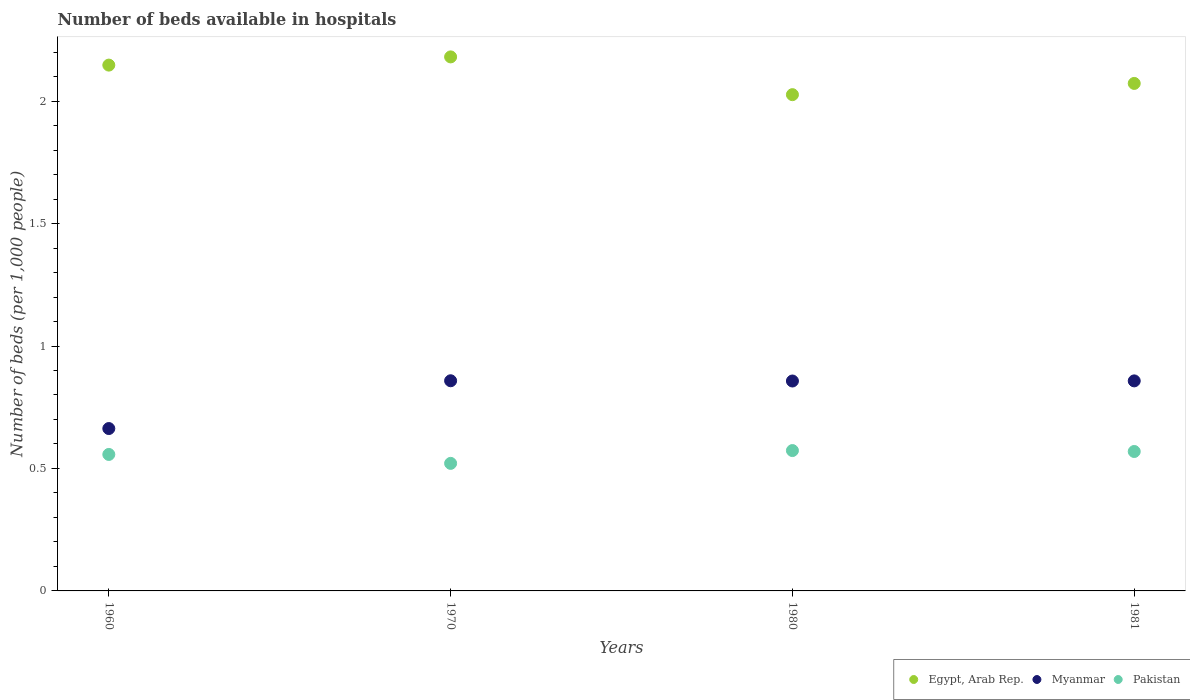Is the number of dotlines equal to the number of legend labels?
Provide a short and direct response. Yes. What is the number of beds in the hospiatls of in Pakistan in 1970?
Your answer should be compact. 0.52. Across all years, what is the maximum number of beds in the hospiatls of in Pakistan?
Provide a succinct answer. 0.57. Across all years, what is the minimum number of beds in the hospiatls of in Egypt, Arab Rep.?
Provide a succinct answer. 2.03. In which year was the number of beds in the hospiatls of in Myanmar maximum?
Offer a very short reply. 1970. In which year was the number of beds in the hospiatls of in Myanmar minimum?
Keep it short and to the point. 1960. What is the total number of beds in the hospiatls of in Myanmar in the graph?
Provide a short and direct response. 3.24. What is the difference between the number of beds in the hospiatls of in Pakistan in 1980 and that in 1981?
Keep it short and to the point. 0. What is the difference between the number of beds in the hospiatls of in Egypt, Arab Rep. in 1981 and the number of beds in the hospiatls of in Pakistan in 1980?
Your response must be concise. 1.5. What is the average number of beds in the hospiatls of in Egypt, Arab Rep. per year?
Offer a very short reply. 2.11. In the year 1981, what is the difference between the number of beds in the hospiatls of in Myanmar and number of beds in the hospiatls of in Pakistan?
Offer a very short reply. 0.29. In how many years, is the number of beds in the hospiatls of in Egypt, Arab Rep. greater than 0.30000000000000004?
Offer a terse response. 4. What is the ratio of the number of beds in the hospiatls of in Egypt, Arab Rep. in 1960 to that in 1970?
Your response must be concise. 0.98. Is the number of beds in the hospiatls of in Egypt, Arab Rep. in 1970 less than that in 1980?
Your answer should be compact. No. What is the difference between the highest and the second highest number of beds in the hospiatls of in Myanmar?
Your answer should be very brief. 0. What is the difference between the highest and the lowest number of beds in the hospiatls of in Pakistan?
Provide a succinct answer. 0.05. Is the sum of the number of beds in the hospiatls of in Egypt, Arab Rep. in 1960 and 1980 greater than the maximum number of beds in the hospiatls of in Myanmar across all years?
Your answer should be compact. Yes. Does the number of beds in the hospiatls of in Myanmar monotonically increase over the years?
Make the answer very short. No. Is the number of beds in the hospiatls of in Myanmar strictly less than the number of beds in the hospiatls of in Egypt, Arab Rep. over the years?
Offer a terse response. Yes. What is the difference between two consecutive major ticks on the Y-axis?
Give a very brief answer. 0.5. How many legend labels are there?
Offer a terse response. 3. How are the legend labels stacked?
Your response must be concise. Horizontal. What is the title of the graph?
Keep it short and to the point. Number of beds available in hospitals. Does "St. Martin (French part)" appear as one of the legend labels in the graph?
Give a very brief answer. No. What is the label or title of the X-axis?
Your answer should be compact. Years. What is the label or title of the Y-axis?
Your response must be concise. Number of beds (per 1,0 people). What is the Number of beds (per 1,000 people) of Egypt, Arab Rep. in 1960?
Keep it short and to the point. 2.15. What is the Number of beds (per 1,000 people) in Myanmar in 1960?
Offer a terse response. 0.66. What is the Number of beds (per 1,000 people) in Pakistan in 1960?
Your answer should be compact. 0.56. What is the Number of beds (per 1,000 people) in Egypt, Arab Rep. in 1970?
Offer a very short reply. 2.18. What is the Number of beds (per 1,000 people) of Myanmar in 1970?
Your response must be concise. 0.86. What is the Number of beds (per 1,000 people) in Pakistan in 1970?
Keep it short and to the point. 0.52. What is the Number of beds (per 1,000 people) of Egypt, Arab Rep. in 1980?
Provide a short and direct response. 2.03. What is the Number of beds (per 1,000 people) in Myanmar in 1980?
Your response must be concise. 0.86. What is the Number of beds (per 1,000 people) of Pakistan in 1980?
Provide a short and direct response. 0.57. What is the Number of beds (per 1,000 people) of Egypt, Arab Rep. in 1981?
Your answer should be compact. 2.07. What is the Number of beds (per 1,000 people) in Myanmar in 1981?
Make the answer very short. 0.86. What is the Number of beds (per 1,000 people) in Pakistan in 1981?
Your response must be concise. 0.57. Across all years, what is the maximum Number of beds (per 1,000 people) of Egypt, Arab Rep.?
Make the answer very short. 2.18. Across all years, what is the maximum Number of beds (per 1,000 people) in Myanmar?
Offer a terse response. 0.86. Across all years, what is the maximum Number of beds (per 1,000 people) in Pakistan?
Your response must be concise. 0.57. Across all years, what is the minimum Number of beds (per 1,000 people) of Egypt, Arab Rep.?
Your answer should be compact. 2.03. Across all years, what is the minimum Number of beds (per 1,000 people) of Myanmar?
Provide a succinct answer. 0.66. Across all years, what is the minimum Number of beds (per 1,000 people) of Pakistan?
Keep it short and to the point. 0.52. What is the total Number of beds (per 1,000 people) in Egypt, Arab Rep. in the graph?
Offer a terse response. 8.43. What is the total Number of beds (per 1,000 people) in Myanmar in the graph?
Keep it short and to the point. 3.24. What is the total Number of beds (per 1,000 people) of Pakistan in the graph?
Give a very brief answer. 2.22. What is the difference between the Number of beds (per 1,000 people) of Egypt, Arab Rep. in 1960 and that in 1970?
Make the answer very short. -0.03. What is the difference between the Number of beds (per 1,000 people) of Myanmar in 1960 and that in 1970?
Offer a very short reply. -0.2. What is the difference between the Number of beds (per 1,000 people) in Pakistan in 1960 and that in 1970?
Offer a terse response. 0.04. What is the difference between the Number of beds (per 1,000 people) in Egypt, Arab Rep. in 1960 and that in 1980?
Make the answer very short. 0.12. What is the difference between the Number of beds (per 1,000 people) in Myanmar in 1960 and that in 1980?
Your answer should be compact. -0.19. What is the difference between the Number of beds (per 1,000 people) in Pakistan in 1960 and that in 1980?
Provide a succinct answer. -0.02. What is the difference between the Number of beds (per 1,000 people) in Egypt, Arab Rep. in 1960 and that in 1981?
Your response must be concise. 0.07. What is the difference between the Number of beds (per 1,000 people) of Myanmar in 1960 and that in 1981?
Provide a succinct answer. -0.19. What is the difference between the Number of beds (per 1,000 people) of Pakistan in 1960 and that in 1981?
Keep it short and to the point. -0.01. What is the difference between the Number of beds (per 1,000 people) in Egypt, Arab Rep. in 1970 and that in 1980?
Provide a succinct answer. 0.15. What is the difference between the Number of beds (per 1,000 people) in Myanmar in 1970 and that in 1980?
Your answer should be very brief. 0. What is the difference between the Number of beds (per 1,000 people) of Pakistan in 1970 and that in 1980?
Your response must be concise. -0.05. What is the difference between the Number of beds (per 1,000 people) of Egypt, Arab Rep. in 1970 and that in 1981?
Your answer should be compact. 0.11. What is the difference between the Number of beds (per 1,000 people) in Myanmar in 1970 and that in 1981?
Make the answer very short. 0. What is the difference between the Number of beds (per 1,000 people) in Pakistan in 1970 and that in 1981?
Make the answer very short. -0.05. What is the difference between the Number of beds (per 1,000 people) of Egypt, Arab Rep. in 1980 and that in 1981?
Make the answer very short. -0.05. What is the difference between the Number of beds (per 1,000 people) of Myanmar in 1980 and that in 1981?
Make the answer very short. -0. What is the difference between the Number of beds (per 1,000 people) of Pakistan in 1980 and that in 1981?
Provide a short and direct response. 0. What is the difference between the Number of beds (per 1,000 people) of Egypt, Arab Rep. in 1960 and the Number of beds (per 1,000 people) of Myanmar in 1970?
Provide a short and direct response. 1.29. What is the difference between the Number of beds (per 1,000 people) in Egypt, Arab Rep. in 1960 and the Number of beds (per 1,000 people) in Pakistan in 1970?
Your answer should be very brief. 1.63. What is the difference between the Number of beds (per 1,000 people) in Myanmar in 1960 and the Number of beds (per 1,000 people) in Pakistan in 1970?
Ensure brevity in your answer.  0.14. What is the difference between the Number of beds (per 1,000 people) of Egypt, Arab Rep. in 1960 and the Number of beds (per 1,000 people) of Myanmar in 1980?
Ensure brevity in your answer.  1.29. What is the difference between the Number of beds (per 1,000 people) in Egypt, Arab Rep. in 1960 and the Number of beds (per 1,000 people) in Pakistan in 1980?
Offer a terse response. 1.57. What is the difference between the Number of beds (per 1,000 people) of Myanmar in 1960 and the Number of beds (per 1,000 people) of Pakistan in 1980?
Your answer should be very brief. 0.09. What is the difference between the Number of beds (per 1,000 people) in Egypt, Arab Rep. in 1960 and the Number of beds (per 1,000 people) in Myanmar in 1981?
Your answer should be very brief. 1.29. What is the difference between the Number of beds (per 1,000 people) of Egypt, Arab Rep. in 1960 and the Number of beds (per 1,000 people) of Pakistan in 1981?
Make the answer very short. 1.58. What is the difference between the Number of beds (per 1,000 people) of Myanmar in 1960 and the Number of beds (per 1,000 people) of Pakistan in 1981?
Offer a very short reply. 0.09. What is the difference between the Number of beds (per 1,000 people) of Egypt, Arab Rep. in 1970 and the Number of beds (per 1,000 people) of Myanmar in 1980?
Offer a very short reply. 1.32. What is the difference between the Number of beds (per 1,000 people) in Egypt, Arab Rep. in 1970 and the Number of beds (per 1,000 people) in Pakistan in 1980?
Make the answer very short. 1.61. What is the difference between the Number of beds (per 1,000 people) in Myanmar in 1970 and the Number of beds (per 1,000 people) in Pakistan in 1980?
Make the answer very short. 0.28. What is the difference between the Number of beds (per 1,000 people) in Egypt, Arab Rep. in 1970 and the Number of beds (per 1,000 people) in Myanmar in 1981?
Your answer should be compact. 1.32. What is the difference between the Number of beds (per 1,000 people) of Egypt, Arab Rep. in 1970 and the Number of beds (per 1,000 people) of Pakistan in 1981?
Your answer should be very brief. 1.61. What is the difference between the Number of beds (per 1,000 people) of Myanmar in 1970 and the Number of beds (per 1,000 people) of Pakistan in 1981?
Your answer should be compact. 0.29. What is the difference between the Number of beds (per 1,000 people) in Egypt, Arab Rep. in 1980 and the Number of beds (per 1,000 people) in Myanmar in 1981?
Make the answer very short. 1.17. What is the difference between the Number of beds (per 1,000 people) in Egypt, Arab Rep. in 1980 and the Number of beds (per 1,000 people) in Pakistan in 1981?
Give a very brief answer. 1.46. What is the difference between the Number of beds (per 1,000 people) of Myanmar in 1980 and the Number of beds (per 1,000 people) of Pakistan in 1981?
Offer a terse response. 0.29. What is the average Number of beds (per 1,000 people) of Egypt, Arab Rep. per year?
Provide a short and direct response. 2.11. What is the average Number of beds (per 1,000 people) in Myanmar per year?
Your answer should be very brief. 0.81. What is the average Number of beds (per 1,000 people) of Pakistan per year?
Offer a very short reply. 0.56. In the year 1960, what is the difference between the Number of beds (per 1,000 people) of Egypt, Arab Rep. and Number of beds (per 1,000 people) of Myanmar?
Make the answer very short. 1.48. In the year 1960, what is the difference between the Number of beds (per 1,000 people) in Egypt, Arab Rep. and Number of beds (per 1,000 people) in Pakistan?
Ensure brevity in your answer.  1.59. In the year 1960, what is the difference between the Number of beds (per 1,000 people) in Myanmar and Number of beds (per 1,000 people) in Pakistan?
Provide a short and direct response. 0.11. In the year 1970, what is the difference between the Number of beds (per 1,000 people) in Egypt, Arab Rep. and Number of beds (per 1,000 people) in Myanmar?
Ensure brevity in your answer.  1.32. In the year 1970, what is the difference between the Number of beds (per 1,000 people) of Egypt, Arab Rep. and Number of beds (per 1,000 people) of Pakistan?
Make the answer very short. 1.66. In the year 1970, what is the difference between the Number of beds (per 1,000 people) in Myanmar and Number of beds (per 1,000 people) in Pakistan?
Ensure brevity in your answer.  0.34. In the year 1980, what is the difference between the Number of beds (per 1,000 people) of Egypt, Arab Rep. and Number of beds (per 1,000 people) of Myanmar?
Provide a succinct answer. 1.17. In the year 1980, what is the difference between the Number of beds (per 1,000 people) of Egypt, Arab Rep. and Number of beds (per 1,000 people) of Pakistan?
Your answer should be compact. 1.45. In the year 1980, what is the difference between the Number of beds (per 1,000 people) of Myanmar and Number of beds (per 1,000 people) of Pakistan?
Offer a terse response. 0.28. In the year 1981, what is the difference between the Number of beds (per 1,000 people) in Egypt, Arab Rep. and Number of beds (per 1,000 people) in Myanmar?
Provide a short and direct response. 1.21. In the year 1981, what is the difference between the Number of beds (per 1,000 people) of Egypt, Arab Rep. and Number of beds (per 1,000 people) of Pakistan?
Ensure brevity in your answer.  1.5. In the year 1981, what is the difference between the Number of beds (per 1,000 people) in Myanmar and Number of beds (per 1,000 people) in Pakistan?
Provide a succinct answer. 0.29. What is the ratio of the Number of beds (per 1,000 people) in Egypt, Arab Rep. in 1960 to that in 1970?
Offer a terse response. 0.98. What is the ratio of the Number of beds (per 1,000 people) in Myanmar in 1960 to that in 1970?
Provide a succinct answer. 0.77. What is the ratio of the Number of beds (per 1,000 people) of Pakistan in 1960 to that in 1970?
Your answer should be compact. 1.07. What is the ratio of the Number of beds (per 1,000 people) of Egypt, Arab Rep. in 1960 to that in 1980?
Ensure brevity in your answer.  1.06. What is the ratio of the Number of beds (per 1,000 people) in Myanmar in 1960 to that in 1980?
Your answer should be very brief. 0.77. What is the ratio of the Number of beds (per 1,000 people) of Pakistan in 1960 to that in 1980?
Provide a succinct answer. 0.97. What is the ratio of the Number of beds (per 1,000 people) of Egypt, Arab Rep. in 1960 to that in 1981?
Offer a terse response. 1.04. What is the ratio of the Number of beds (per 1,000 people) of Myanmar in 1960 to that in 1981?
Provide a succinct answer. 0.77. What is the ratio of the Number of beds (per 1,000 people) in Pakistan in 1960 to that in 1981?
Give a very brief answer. 0.98. What is the ratio of the Number of beds (per 1,000 people) in Egypt, Arab Rep. in 1970 to that in 1980?
Make the answer very short. 1.08. What is the ratio of the Number of beds (per 1,000 people) in Myanmar in 1970 to that in 1980?
Provide a succinct answer. 1. What is the ratio of the Number of beds (per 1,000 people) of Pakistan in 1970 to that in 1980?
Your response must be concise. 0.91. What is the ratio of the Number of beds (per 1,000 people) of Egypt, Arab Rep. in 1970 to that in 1981?
Offer a terse response. 1.05. What is the ratio of the Number of beds (per 1,000 people) of Myanmar in 1970 to that in 1981?
Make the answer very short. 1. What is the ratio of the Number of beds (per 1,000 people) in Pakistan in 1970 to that in 1981?
Give a very brief answer. 0.91. What is the ratio of the Number of beds (per 1,000 people) in Egypt, Arab Rep. in 1980 to that in 1981?
Give a very brief answer. 0.98. What is the ratio of the Number of beds (per 1,000 people) in Pakistan in 1980 to that in 1981?
Your answer should be compact. 1.01. What is the difference between the highest and the second highest Number of beds (per 1,000 people) in Egypt, Arab Rep.?
Offer a terse response. 0.03. What is the difference between the highest and the second highest Number of beds (per 1,000 people) in Pakistan?
Provide a succinct answer. 0. What is the difference between the highest and the lowest Number of beds (per 1,000 people) of Egypt, Arab Rep.?
Provide a short and direct response. 0.15. What is the difference between the highest and the lowest Number of beds (per 1,000 people) in Myanmar?
Offer a very short reply. 0.2. What is the difference between the highest and the lowest Number of beds (per 1,000 people) of Pakistan?
Ensure brevity in your answer.  0.05. 